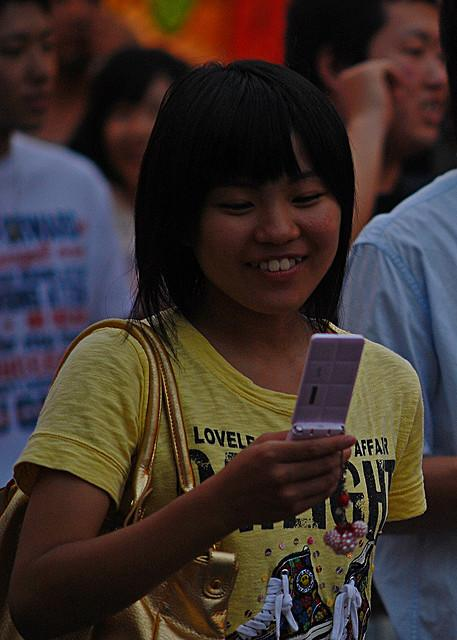What is there a picture of on the yellow shirt? Please explain your reasoning. shoes. The picture is shoes. 